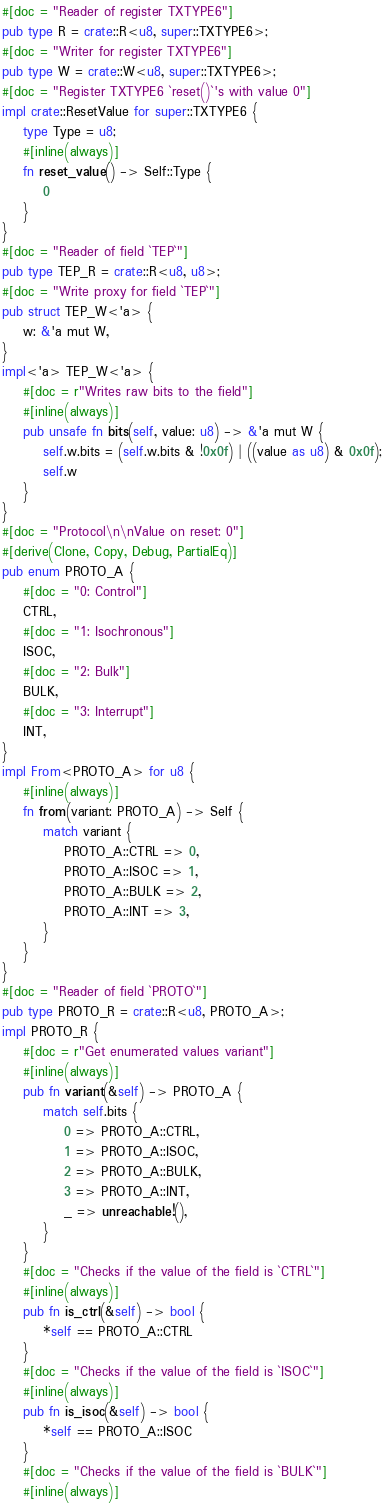Convert code to text. <code><loc_0><loc_0><loc_500><loc_500><_Rust_>#[doc = "Reader of register TXTYPE6"]
pub type R = crate::R<u8, super::TXTYPE6>;
#[doc = "Writer for register TXTYPE6"]
pub type W = crate::W<u8, super::TXTYPE6>;
#[doc = "Register TXTYPE6 `reset()`'s with value 0"]
impl crate::ResetValue for super::TXTYPE6 {
    type Type = u8;
    #[inline(always)]
    fn reset_value() -> Self::Type {
        0
    }
}
#[doc = "Reader of field `TEP`"]
pub type TEP_R = crate::R<u8, u8>;
#[doc = "Write proxy for field `TEP`"]
pub struct TEP_W<'a> {
    w: &'a mut W,
}
impl<'a> TEP_W<'a> {
    #[doc = r"Writes raw bits to the field"]
    #[inline(always)]
    pub unsafe fn bits(self, value: u8) -> &'a mut W {
        self.w.bits = (self.w.bits & !0x0f) | ((value as u8) & 0x0f);
        self.w
    }
}
#[doc = "Protocol\n\nValue on reset: 0"]
#[derive(Clone, Copy, Debug, PartialEq)]
pub enum PROTO_A {
    #[doc = "0: Control"]
    CTRL,
    #[doc = "1: Isochronous"]
    ISOC,
    #[doc = "2: Bulk"]
    BULK,
    #[doc = "3: Interrupt"]
    INT,
}
impl From<PROTO_A> for u8 {
    #[inline(always)]
    fn from(variant: PROTO_A) -> Self {
        match variant {
            PROTO_A::CTRL => 0,
            PROTO_A::ISOC => 1,
            PROTO_A::BULK => 2,
            PROTO_A::INT => 3,
        }
    }
}
#[doc = "Reader of field `PROTO`"]
pub type PROTO_R = crate::R<u8, PROTO_A>;
impl PROTO_R {
    #[doc = r"Get enumerated values variant"]
    #[inline(always)]
    pub fn variant(&self) -> PROTO_A {
        match self.bits {
            0 => PROTO_A::CTRL,
            1 => PROTO_A::ISOC,
            2 => PROTO_A::BULK,
            3 => PROTO_A::INT,
            _ => unreachable!(),
        }
    }
    #[doc = "Checks if the value of the field is `CTRL`"]
    #[inline(always)]
    pub fn is_ctrl(&self) -> bool {
        *self == PROTO_A::CTRL
    }
    #[doc = "Checks if the value of the field is `ISOC`"]
    #[inline(always)]
    pub fn is_isoc(&self) -> bool {
        *self == PROTO_A::ISOC
    }
    #[doc = "Checks if the value of the field is `BULK`"]
    #[inline(always)]</code> 